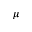<formula> <loc_0><loc_0><loc_500><loc_500>\mu</formula> 